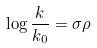Convert formula to latex. <formula><loc_0><loc_0><loc_500><loc_500>\log \frac { k } { k _ { 0 } } = \sigma \rho</formula> 